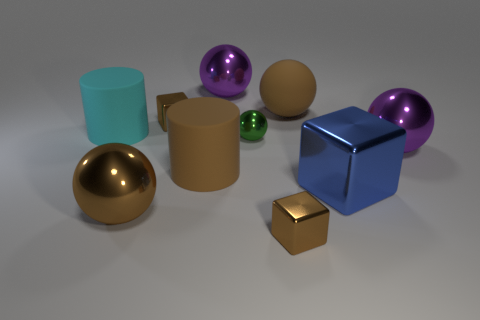There is a purple sphere that is to the left of the purple shiny thing right of the big blue thing; what size is it?
Give a very brief answer. Large. The green object has what size?
Your answer should be compact. Small. There is a rubber cylinder that is to the right of the cyan rubber cylinder; is its color the same as the big metallic ball that is to the right of the green metallic sphere?
Your response must be concise. No. What number of other objects are the same material as the tiny green sphere?
Your answer should be compact. 6. Are there any big matte cylinders?
Keep it short and to the point. Yes. Is the small brown block that is behind the big blue object made of the same material as the brown cylinder?
Make the answer very short. No. What material is the brown thing that is the same shape as the cyan matte object?
Ensure brevity in your answer.  Rubber. There is a big cylinder that is the same color as the big rubber ball; what material is it?
Your answer should be compact. Rubber. Is the number of brown cubes less than the number of big metal balls?
Your response must be concise. Yes. Does the small metal cube that is behind the blue cube have the same color as the matte ball?
Keep it short and to the point. Yes. 